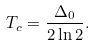Convert formula to latex. <formula><loc_0><loc_0><loc_500><loc_500>T _ { c } = \frac { \Delta _ { 0 } } { 2 \ln 2 } .</formula> 